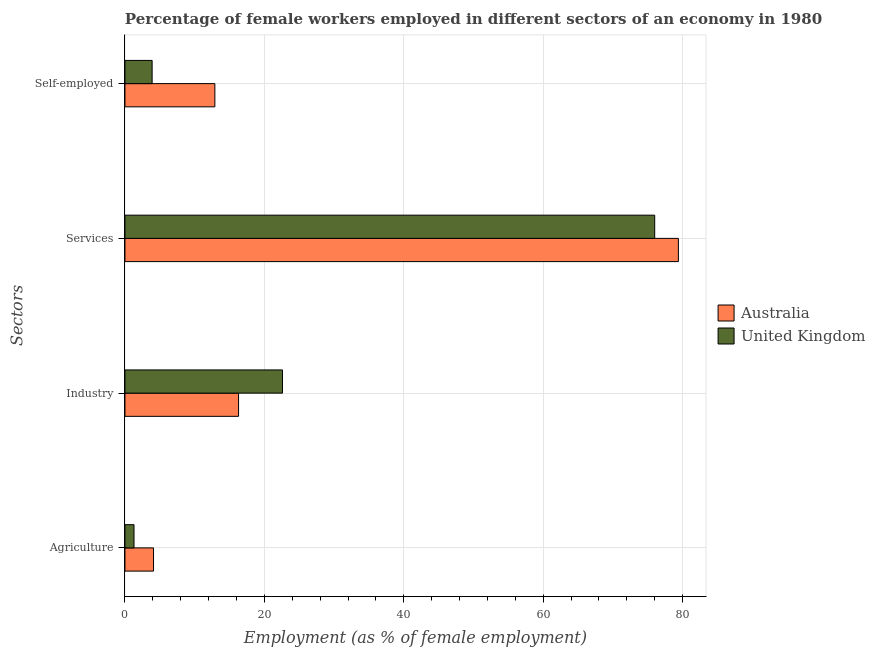How many groups of bars are there?
Keep it short and to the point. 4. Are the number of bars on each tick of the Y-axis equal?
Offer a very short reply. Yes. How many bars are there on the 1st tick from the top?
Make the answer very short. 2. What is the label of the 1st group of bars from the top?
Offer a terse response. Self-employed. What is the percentage of female workers in industry in Australia?
Your answer should be compact. 16.3. Across all countries, what is the maximum percentage of self employed female workers?
Provide a succinct answer. 12.9. Across all countries, what is the minimum percentage of female workers in agriculture?
Your answer should be very brief. 1.3. In which country was the percentage of female workers in agriculture minimum?
Make the answer very short. United Kingdom. What is the total percentage of female workers in industry in the graph?
Ensure brevity in your answer.  38.9. What is the difference between the percentage of female workers in services in Australia and that in United Kingdom?
Offer a very short reply. 3.4. What is the difference between the percentage of female workers in industry in United Kingdom and the percentage of female workers in agriculture in Australia?
Offer a terse response. 18.5. What is the average percentage of self employed female workers per country?
Your answer should be very brief. 8.4. What is the difference between the percentage of female workers in agriculture and percentage of female workers in industry in United Kingdom?
Keep it short and to the point. -21.3. What is the ratio of the percentage of self employed female workers in United Kingdom to that in Australia?
Keep it short and to the point. 0.3. Is the percentage of female workers in services in Australia less than that in United Kingdom?
Your answer should be very brief. No. What is the difference between the highest and the second highest percentage of female workers in agriculture?
Provide a short and direct response. 2.8. What is the difference between the highest and the lowest percentage of female workers in services?
Your response must be concise. 3.4. Is it the case that in every country, the sum of the percentage of female workers in agriculture and percentage of female workers in industry is greater than the percentage of female workers in services?
Make the answer very short. No. Are all the bars in the graph horizontal?
Make the answer very short. Yes. How many countries are there in the graph?
Ensure brevity in your answer.  2. Are the values on the major ticks of X-axis written in scientific E-notation?
Keep it short and to the point. No. How are the legend labels stacked?
Your answer should be very brief. Vertical. What is the title of the graph?
Your answer should be compact. Percentage of female workers employed in different sectors of an economy in 1980. Does "Sweden" appear as one of the legend labels in the graph?
Your response must be concise. No. What is the label or title of the X-axis?
Your response must be concise. Employment (as % of female employment). What is the label or title of the Y-axis?
Make the answer very short. Sectors. What is the Employment (as % of female employment) in Australia in Agriculture?
Offer a terse response. 4.1. What is the Employment (as % of female employment) of United Kingdom in Agriculture?
Your answer should be compact. 1.3. What is the Employment (as % of female employment) of Australia in Industry?
Your answer should be compact. 16.3. What is the Employment (as % of female employment) in United Kingdom in Industry?
Give a very brief answer. 22.6. What is the Employment (as % of female employment) in Australia in Services?
Your response must be concise. 79.4. What is the Employment (as % of female employment) of Australia in Self-employed?
Your response must be concise. 12.9. What is the Employment (as % of female employment) of United Kingdom in Self-employed?
Make the answer very short. 3.9. Across all Sectors, what is the maximum Employment (as % of female employment) of Australia?
Provide a short and direct response. 79.4. Across all Sectors, what is the maximum Employment (as % of female employment) in United Kingdom?
Keep it short and to the point. 76. Across all Sectors, what is the minimum Employment (as % of female employment) of Australia?
Provide a succinct answer. 4.1. Across all Sectors, what is the minimum Employment (as % of female employment) of United Kingdom?
Offer a terse response. 1.3. What is the total Employment (as % of female employment) of Australia in the graph?
Your answer should be very brief. 112.7. What is the total Employment (as % of female employment) of United Kingdom in the graph?
Your answer should be very brief. 103.8. What is the difference between the Employment (as % of female employment) in United Kingdom in Agriculture and that in Industry?
Your answer should be very brief. -21.3. What is the difference between the Employment (as % of female employment) of Australia in Agriculture and that in Services?
Offer a very short reply. -75.3. What is the difference between the Employment (as % of female employment) in United Kingdom in Agriculture and that in Services?
Your answer should be very brief. -74.7. What is the difference between the Employment (as % of female employment) of United Kingdom in Agriculture and that in Self-employed?
Provide a short and direct response. -2.6. What is the difference between the Employment (as % of female employment) in Australia in Industry and that in Services?
Your answer should be very brief. -63.1. What is the difference between the Employment (as % of female employment) of United Kingdom in Industry and that in Services?
Your answer should be very brief. -53.4. What is the difference between the Employment (as % of female employment) of Australia in Industry and that in Self-employed?
Offer a very short reply. 3.4. What is the difference between the Employment (as % of female employment) of United Kingdom in Industry and that in Self-employed?
Keep it short and to the point. 18.7. What is the difference between the Employment (as % of female employment) in Australia in Services and that in Self-employed?
Offer a very short reply. 66.5. What is the difference between the Employment (as % of female employment) of United Kingdom in Services and that in Self-employed?
Offer a terse response. 72.1. What is the difference between the Employment (as % of female employment) of Australia in Agriculture and the Employment (as % of female employment) of United Kingdom in Industry?
Your answer should be compact. -18.5. What is the difference between the Employment (as % of female employment) in Australia in Agriculture and the Employment (as % of female employment) in United Kingdom in Services?
Your answer should be very brief. -71.9. What is the difference between the Employment (as % of female employment) of Australia in Industry and the Employment (as % of female employment) of United Kingdom in Services?
Your answer should be compact. -59.7. What is the difference between the Employment (as % of female employment) in Australia in Services and the Employment (as % of female employment) in United Kingdom in Self-employed?
Offer a terse response. 75.5. What is the average Employment (as % of female employment) of Australia per Sectors?
Your response must be concise. 28.18. What is the average Employment (as % of female employment) of United Kingdom per Sectors?
Offer a terse response. 25.95. What is the difference between the Employment (as % of female employment) in Australia and Employment (as % of female employment) in United Kingdom in Industry?
Give a very brief answer. -6.3. What is the difference between the Employment (as % of female employment) in Australia and Employment (as % of female employment) in United Kingdom in Services?
Provide a short and direct response. 3.4. What is the difference between the Employment (as % of female employment) of Australia and Employment (as % of female employment) of United Kingdom in Self-employed?
Keep it short and to the point. 9. What is the ratio of the Employment (as % of female employment) in Australia in Agriculture to that in Industry?
Your answer should be very brief. 0.25. What is the ratio of the Employment (as % of female employment) in United Kingdom in Agriculture to that in Industry?
Keep it short and to the point. 0.06. What is the ratio of the Employment (as % of female employment) in Australia in Agriculture to that in Services?
Your response must be concise. 0.05. What is the ratio of the Employment (as % of female employment) in United Kingdom in Agriculture to that in Services?
Provide a short and direct response. 0.02. What is the ratio of the Employment (as % of female employment) in Australia in Agriculture to that in Self-employed?
Your answer should be very brief. 0.32. What is the ratio of the Employment (as % of female employment) of United Kingdom in Agriculture to that in Self-employed?
Make the answer very short. 0.33. What is the ratio of the Employment (as % of female employment) of Australia in Industry to that in Services?
Provide a succinct answer. 0.21. What is the ratio of the Employment (as % of female employment) of United Kingdom in Industry to that in Services?
Provide a succinct answer. 0.3. What is the ratio of the Employment (as % of female employment) in Australia in Industry to that in Self-employed?
Keep it short and to the point. 1.26. What is the ratio of the Employment (as % of female employment) in United Kingdom in Industry to that in Self-employed?
Make the answer very short. 5.79. What is the ratio of the Employment (as % of female employment) in Australia in Services to that in Self-employed?
Your answer should be very brief. 6.16. What is the ratio of the Employment (as % of female employment) in United Kingdom in Services to that in Self-employed?
Your response must be concise. 19.49. What is the difference between the highest and the second highest Employment (as % of female employment) of Australia?
Your answer should be very brief. 63.1. What is the difference between the highest and the second highest Employment (as % of female employment) in United Kingdom?
Offer a very short reply. 53.4. What is the difference between the highest and the lowest Employment (as % of female employment) in Australia?
Your answer should be compact. 75.3. What is the difference between the highest and the lowest Employment (as % of female employment) in United Kingdom?
Offer a very short reply. 74.7. 